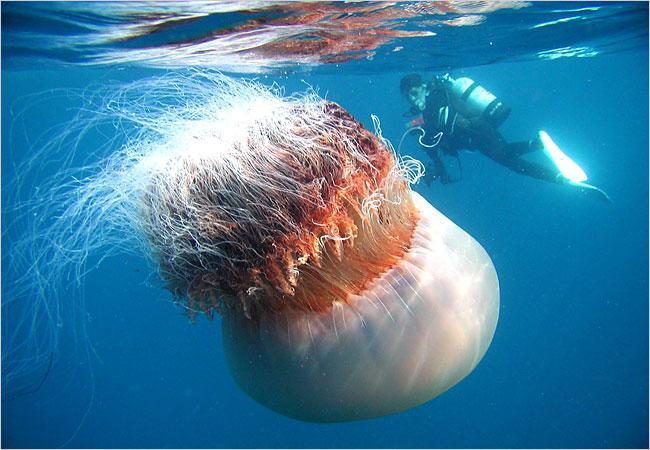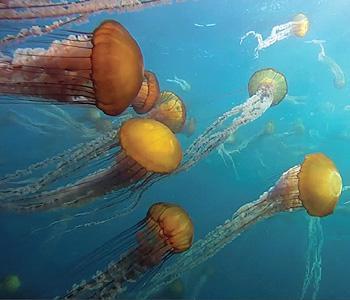The first image is the image on the left, the second image is the image on the right. For the images displayed, is the sentence "One image shows exactly one peachy colored jellyfish, and no scuba diver present." factually correct? Answer yes or no. No. The first image is the image on the left, the second image is the image on the right. Given the left and right images, does the statement "There are two jellyfish, each one traveling the opposite direction as the other." hold true? Answer yes or no. No. 